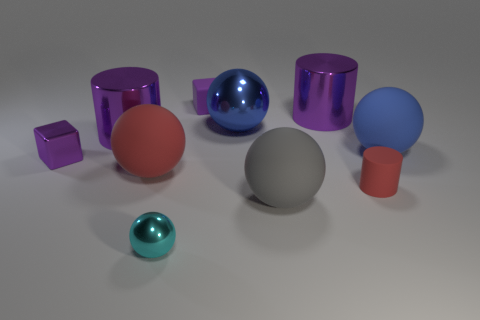Subtract all small balls. How many balls are left? 4 Subtract all cyan spheres. How many spheres are left? 4 Subtract all purple balls. Subtract all purple cylinders. How many balls are left? 5 Subtract all blocks. How many objects are left? 8 Subtract all large purple shiny objects. Subtract all cyan things. How many objects are left? 7 Add 3 blue metallic balls. How many blue metallic balls are left? 4 Add 3 cyan metal spheres. How many cyan metal spheres exist? 4 Subtract 0 yellow cylinders. How many objects are left? 10 